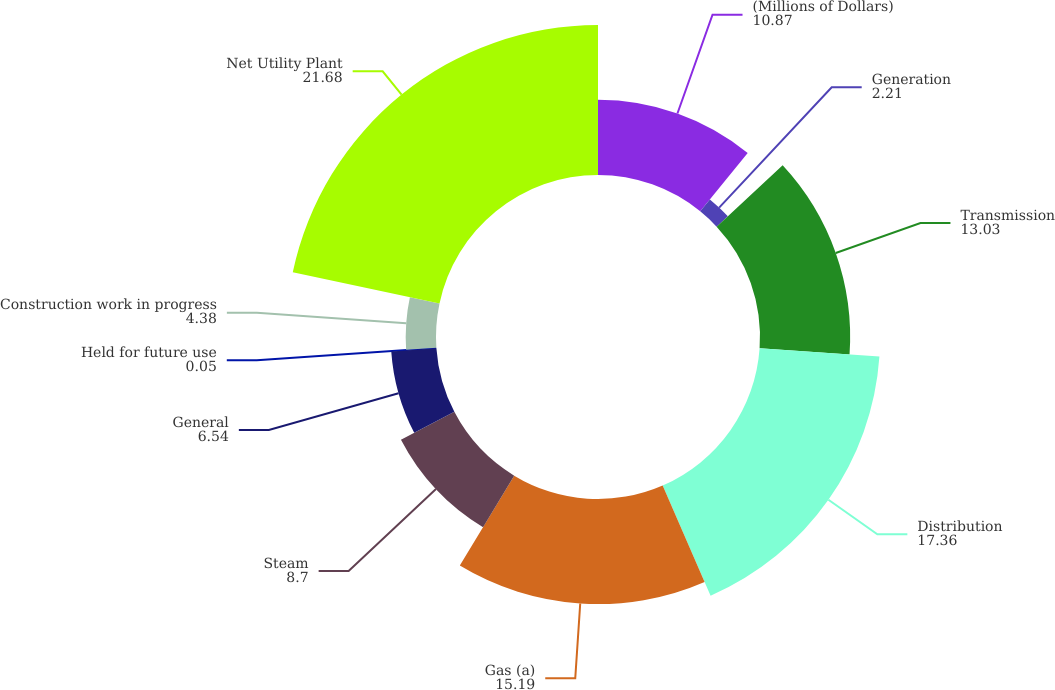Convert chart to OTSL. <chart><loc_0><loc_0><loc_500><loc_500><pie_chart><fcel>(Millions of Dollars)<fcel>Generation<fcel>Transmission<fcel>Distribution<fcel>Gas (a)<fcel>Steam<fcel>General<fcel>Held for future use<fcel>Construction work in progress<fcel>Net Utility Plant<nl><fcel>10.87%<fcel>2.21%<fcel>13.03%<fcel>17.36%<fcel>15.19%<fcel>8.7%<fcel>6.54%<fcel>0.05%<fcel>4.38%<fcel>21.68%<nl></chart> 